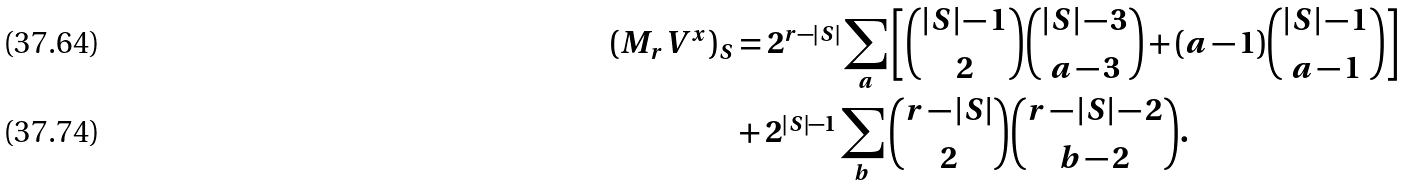Convert formula to latex. <formula><loc_0><loc_0><loc_500><loc_500>( M _ { r } { V } ^ { x } ) _ { S } & = 2 ^ { r - | S | } \sum _ { a } \left [ \binom { | S | - 1 } { 2 } \binom { | S | - 3 } { a - 3 } + ( a - 1 ) \binom { | S | - 1 } { a - 1 } \right ] \\ & + 2 ^ { | S | - 1 } \sum _ { b } \binom { r - | S | } { 2 } \binom { r - | S | - 2 } { b - 2 } .</formula> 